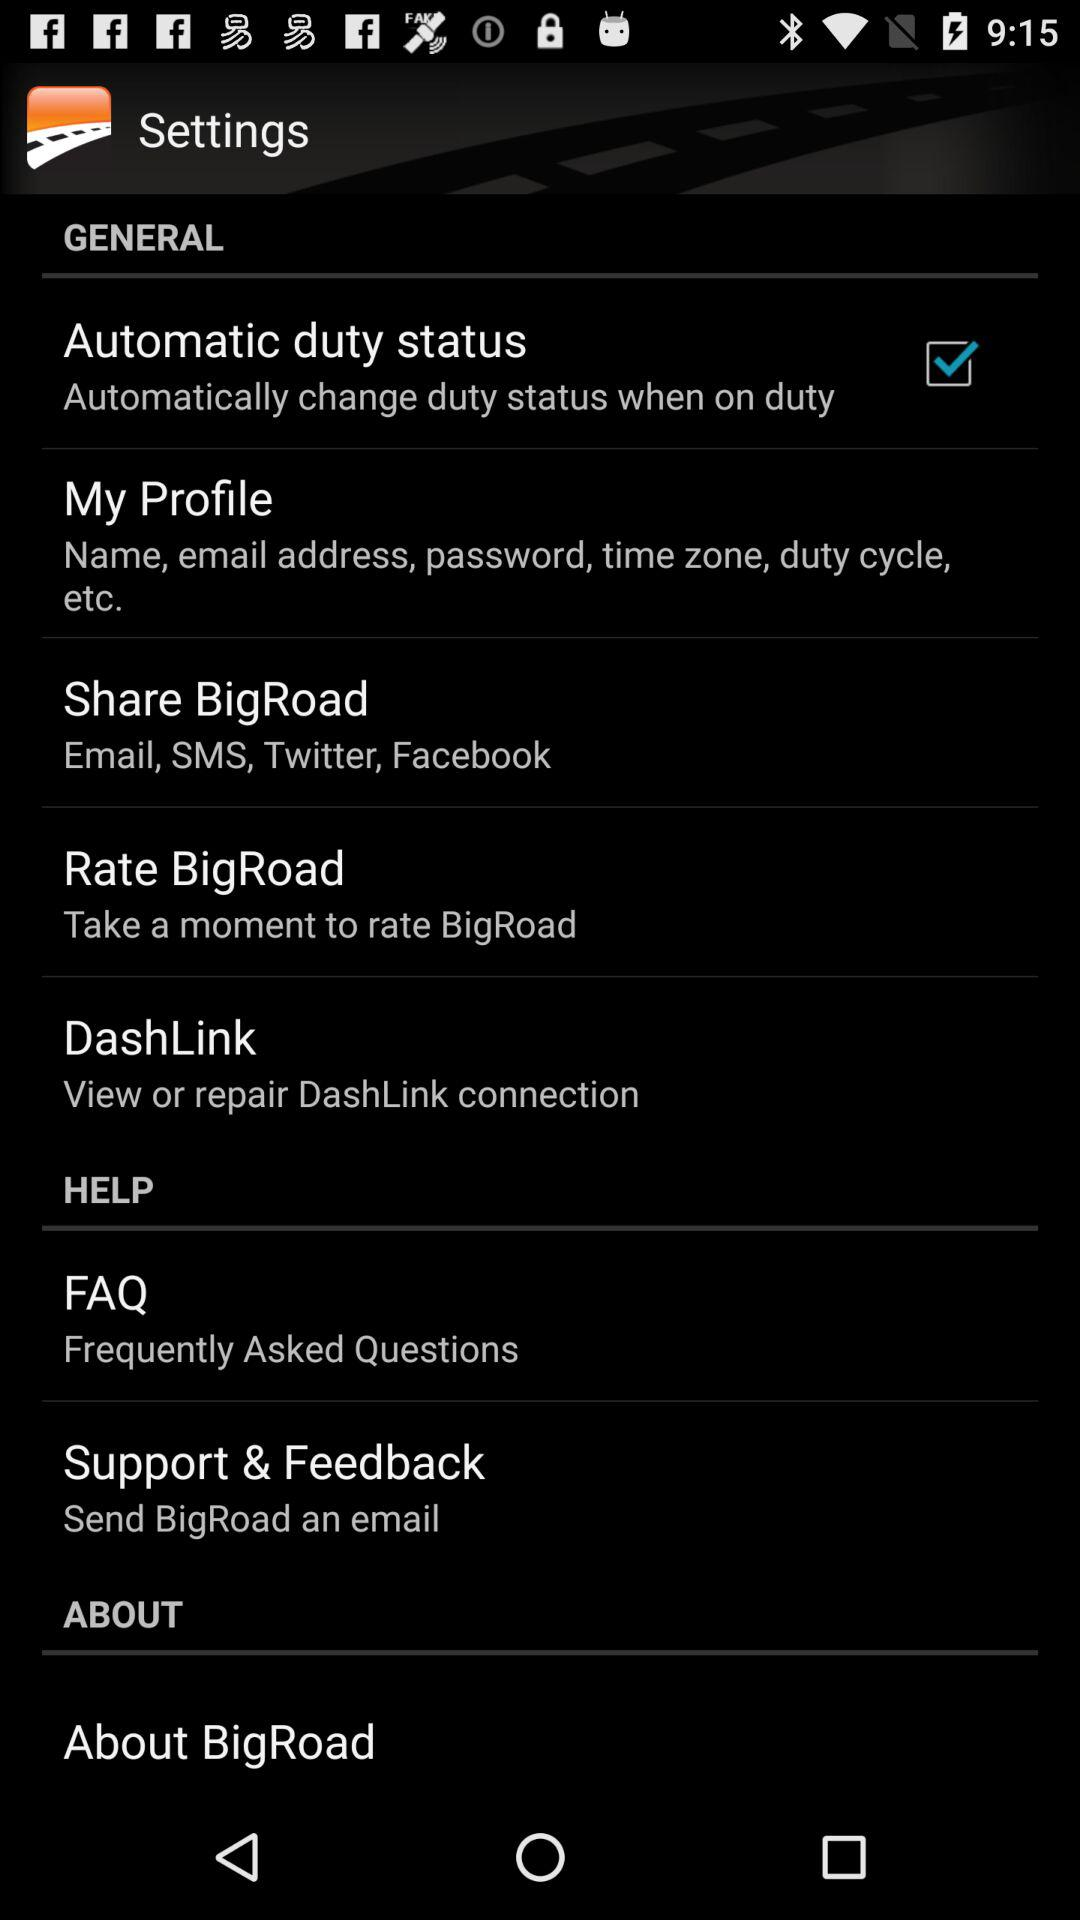What applications can be used to share "BigRoad"? The applications that can be used to share "BigRoad" are "Twitter" and "Facebook". 